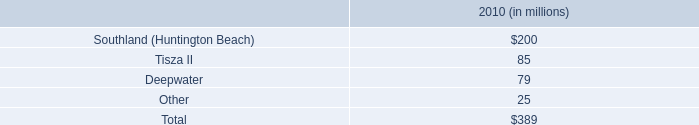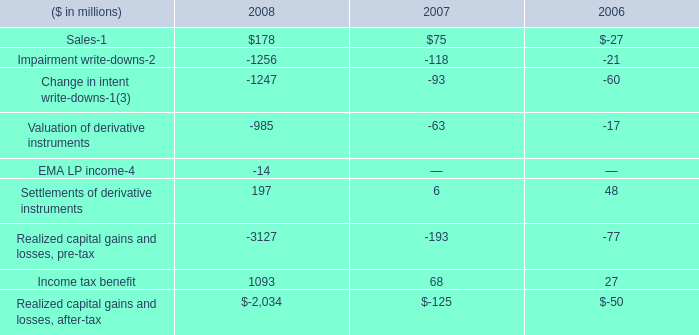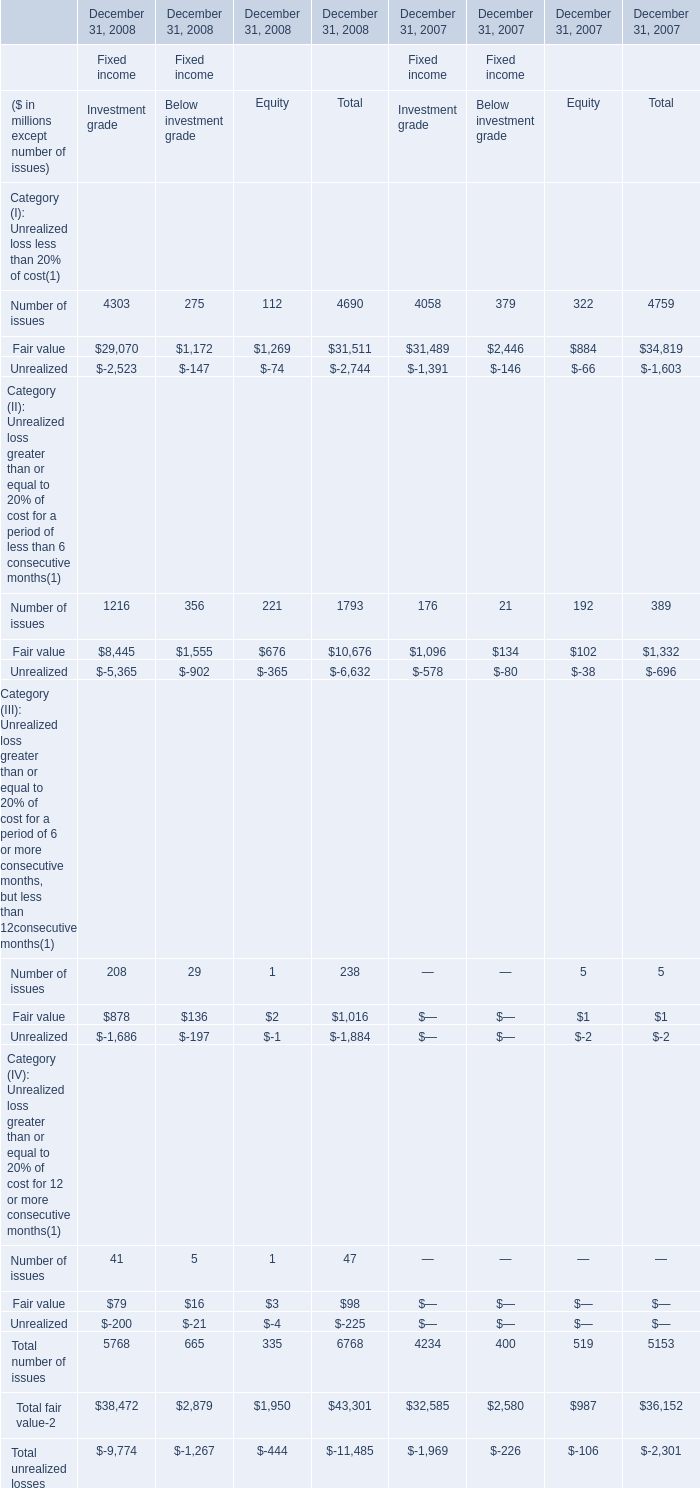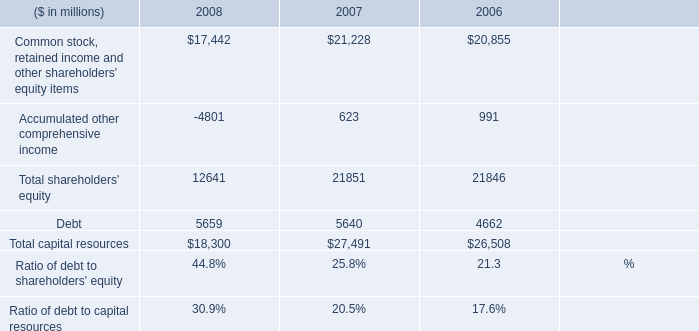What's the sum of the Debt in the years where Settlements of derivative instruments is greater than 0? (in million) 
Computations: ((5659 + 5640) + 4662)
Answer: 15961.0. 